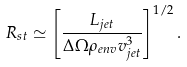Convert formula to latex. <formula><loc_0><loc_0><loc_500><loc_500>R _ { s t } \simeq \left [ \frac { L _ { j e t } } { \Delta \Omega \rho _ { e n v } v _ { j e t } ^ { 3 } } \right ] ^ { 1 / 2 } .</formula> 